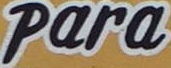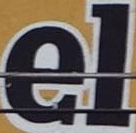What text is displayed in these images sequentially, separated by a semicolon? Para; el 